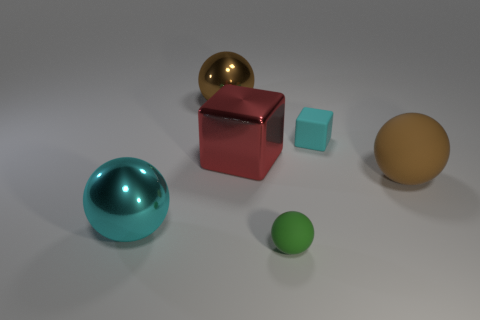What is the shape of the matte thing that is the same size as the cyan block?
Provide a succinct answer. Sphere. Is the number of large red metal objects less than the number of big purple metal blocks?
Offer a terse response. No. How many brown rubber spheres have the same size as the green thing?
Your response must be concise. 0. There is a big object that is the same color as the tiny block; what is its shape?
Keep it short and to the point. Sphere. What material is the small cyan thing?
Offer a very short reply. Rubber. What size is the metal sphere in front of the brown metal thing?
Give a very brief answer. Large. What number of small rubber things are the same shape as the red metallic thing?
Offer a terse response. 1. What shape is the red thing that is the same material as the cyan ball?
Offer a very short reply. Cube. What number of purple objects are rubber balls or metal spheres?
Provide a succinct answer. 0. Are there any large cyan shiny objects in front of the large cyan thing?
Make the answer very short. No. 